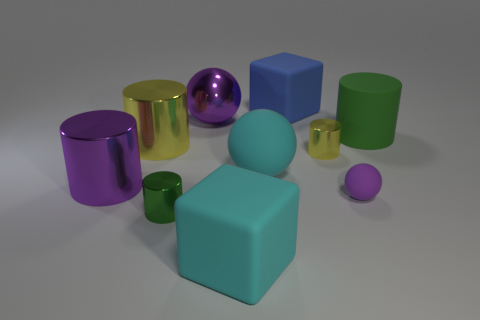Is there any sense of movement or stillness in the scene, and what contributes to that impression? The scene conveys a sense of stillness. The objects are stationary and arranged in a manner that suggests a static display rather than action. This impression is further enhanced by the lack of dynamic elements or indications of motion, such as blurred objects or shadows cast in a particular direction that might suggest movement. 